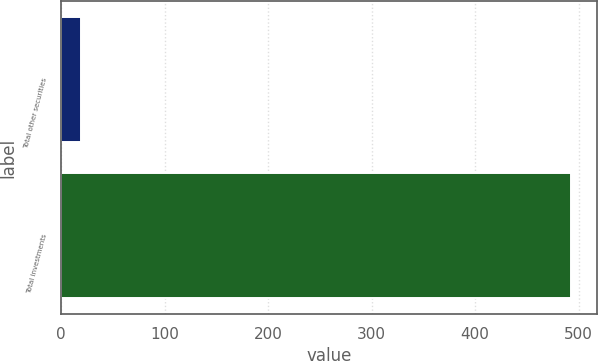<chart> <loc_0><loc_0><loc_500><loc_500><bar_chart><fcel>Total other securities<fcel>Total investments<nl><fcel>19<fcel>493<nl></chart> 